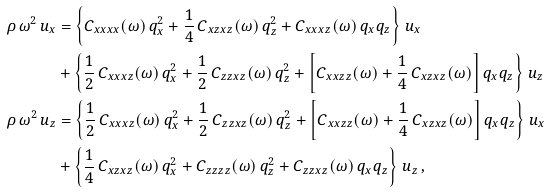Convert formula to latex. <formula><loc_0><loc_0><loc_500><loc_500>\rho \, \omega ^ { 2 } \, u _ { x } & = \left \{ C _ { x x x x } ( \omega ) \, q _ { x } ^ { 2 } + \frac { 1 } { 4 } \, C _ { x z x z } ( \omega ) \, q _ { z } ^ { 2 } + C _ { x x x z } ( \omega ) \, q _ { x } q _ { z } \right \} \, u _ { x } \\ & + \left \{ \frac { 1 } { 2 } \, C _ { x x x z } ( \omega ) \, q _ { x } ^ { 2 } + \frac { 1 } { 2 } \, C _ { z z x z } ( \omega ) \, q _ { z } ^ { 2 } + \left [ C _ { x x z z } ( \omega ) + \frac { 1 } { 4 } \, C _ { x z x z } ( \omega ) \right ] q _ { x } q _ { z } \right \} \, u _ { z } \\ \rho \, \omega ^ { 2 } \, u _ { z } & = \left \{ \frac { 1 } { 2 } \, C _ { x x x z } ( \omega ) \, q _ { x } ^ { 2 } + \frac { 1 } { 2 } \, C _ { z z x z } ( \omega ) \, q _ { z } ^ { 2 } + \left [ C _ { x x z z } ( \omega ) + \frac { 1 } { 4 } \, C _ { x z x z } ( \omega ) \right ] q _ { x } q _ { z } \right \} \, u _ { x } \\ & + \left \{ \frac { 1 } { 4 } \, C _ { x z x z } ( \omega ) \, q _ { x } ^ { 2 } + C _ { z z z z } ( \omega ) \, q _ { z } ^ { 2 } + C _ { z z x z } ( \omega ) \, q _ { x } q _ { z } \right \} \, u _ { z } \, ,</formula> 